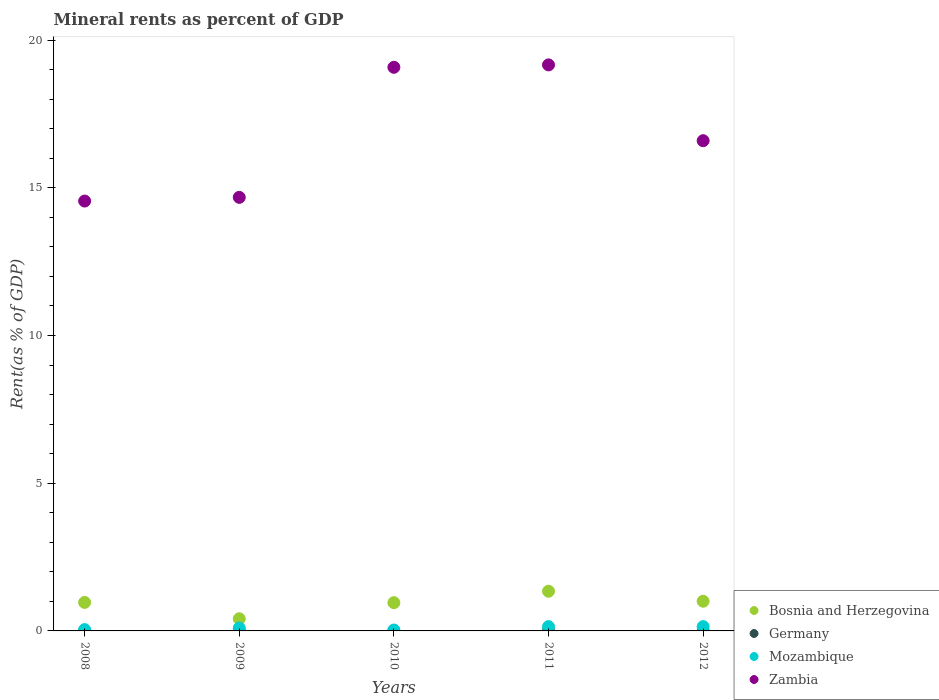How many different coloured dotlines are there?
Give a very brief answer. 4. What is the mineral rent in Germany in 2009?
Ensure brevity in your answer.  0. Across all years, what is the maximum mineral rent in Bosnia and Herzegovina?
Keep it short and to the point. 1.34. Across all years, what is the minimum mineral rent in Germany?
Offer a terse response. 0. What is the total mineral rent in Germany in the graph?
Offer a very short reply. 0.01. What is the difference between the mineral rent in Germany in 2008 and that in 2010?
Your answer should be compact. 0. What is the difference between the mineral rent in Bosnia and Herzegovina in 2008 and the mineral rent in Mozambique in 2010?
Give a very brief answer. 0.93. What is the average mineral rent in Zambia per year?
Ensure brevity in your answer.  16.81. In the year 2009, what is the difference between the mineral rent in Germany and mineral rent in Zambia?
Offer a very short reply. -14.68. In how many years, is the mineral rent in Mozambique greater than 14 %?
Your answer should be compact. 0. What is the ratio of the mineral rent in Bosnia and Herzegovina in 2010 to that in 2011?
Make the answer very short. 0.71. Is the mineral rent in Germany in 2008 less than that in 2012?
Keep it short and to the point. No. What is the difference between the highest and the second highest mineral rent in Bosnia and Herzegovina?
Offer a very short reply. 0.34. What is the difference between the highest and the lowest mineral rent in Zambia?
Offer a terse response. 4.61. Is it the case that in every year, the sum of the mineral rent in Mozambique and mineral rent in Zambia  is greater than the sum of mineral rent in Germany and mineral rent in Bosnia and Herzegovina?
Your response must be concise. No. How many dotlines are there?
Offer a terse response. 4. Are the values on the major ticks of Y-axis written in scientific E-notation?
Provide a short and direct response. No. Does the graph contain any zero values?
Offer a terse response. No. Does the graph contain grids?
Ensure brevity in your answer.  No. What is the title of the graph?
Your answer should be compact. Mineral rents as percent of GDP. What is the label or title of the Y-axis?
Offer a terse response. Rent(as % of GDP). What is the Rent(as % of GDP) of Bosnia and Herzegovina in 2008?
Your answer should be compact. 0.96. What is the Rent(as % of GDP) in Germany in 2008?
Make the answer very short. 0. What is the Rent(as % of GDP) in Mozambique in 2008?
Offer a terse response. 0.05. What is the Rent(as % of GDP) of Zambia in 2008?
Provide a short and direct response. 14.55. What is the Rent(as % of GDP) in Bosnia and Herzegovina in 2009?
Make the answer very short. 0.41. What is the Rent(as % of GDP) in Germany in 2009?
Your answer should be very brief. 0. What is the Rent(as % of GDP) of Mozambique in 2009?
Offer a very short reply. 0.1. What is the Rent(as % of GDP) of Zambia in 2009?
Provide a short and direct response. 14.68. What is the Rent(as % of GDP) of Bosnia and Herzegovina in 2010?
Make the answer very short. 0.96. What is the Rent(as % of GDP) of Germany in 2010?
Offer a terse response. 0. What is the Rent(as % of GDP) in Mozambique in 2010?
Your response must be concise. 0.03. What is the Rent(as % of GDP) of Zambia in 2010?
Make the answer very short. 19.08. What is the Rent(as % of GDP) of Bosnia and Herzegovina in 2011?
Provide a short and direct response. 1.34. What is the Rent(as % of GDP) of Germany in 2011?
Ensure brevity in your answer.  0. What is the Rent(as % of GDP) of Mozambique in 2011?
Provide a short and direct response. 0.15. What is the Rent(as % of GDP) of Zambia in 2011?
Your answer should be very brief. 19.16. What is the Rent(as % of GDP) in Bosnia and Herzegovina in 2012?
Your response must be concise. 1.01. What is the Rent(as % of GDP) in Germany in 2012?
Provide a short and direct response. 0. What is the Rent(as % of GDP) in Mozambique in 2012?
Offer a terse response. 0.15. What is the Rent(as % of GDP) of Zambia in 2012?
Provide a short and direct response. 16.6. Across all years, what is the maximum Rent(as % of GDP) of Bosnia and Herzegovina?
Offer a very short reply. 1.34. Across all years, what is the maximum Rent(as % of GDP) in Germany?
Make the answer very short. 0. Across all years, what is the maximum Rent(as % of GDP) of Mozambique?
Ensure brevity in your answer.  0.15. Across all years, what is the maximum Rent(as % of GDP) in Zambia?
Your answer should be very brief. 19.16. Across all years, what is the minimum Rent(as % of GDP) of Bosnia and Herzegovina?
Provide a short and direct response. 0.41. Across all years, what is the minimum Rent(as % of GDP) in Germany?
Give a very brief answer. 0. Across all years, what is the minimum Rent(as % of GDP) in Mozambique?
Your answer should be very brief. 0.03. Across all years, what is the minimum Rent(as % of GDP) in Zambia?
Offer a very short reply. 14.55. What is the total Rent(as % of GDP) of Bosnia and Herzegovina in the graph?
Your response must be concise. 4.68. What is the total Rent(as % of GDP) of Germany in the graph?
Provide a short and direct response. 0.01. What is the total Rent(as % of GDP) in Mozambique in the graph?
Keep it short and to the point. 0.47. What is the total Rent(as % of GDP) of Zambia in the graph?
Offer a terse response. 84.07. What is the difference between the Rent(as % of GDP) in Bosnia and Herzegovina in 2008 and that in 2009?
Your answer should be very brief. 0.55. What is the difference between the Rent(as % of GDP) in Germany in 2008 and that in 2009?
Ensure brevity in your answer.  0. What is the difference between the Rent(as % of GDP) of Mozambique in 2008 and that in 2009?
Offer a terse response. -0.05. What is the difference between the Rent(as % of GDP) in Zambia in 2008 and that in 2009?
Offer a terse response. -0.13. What is the difference between the Rent(as % of GDP) in Bosnia and Herzegovina in 2008 and that in 2010?
Make the answer very short. 0.01. What is the difference between the Rent(as % of GDP) in Germany in 2008 and that in 2010?
Your response must be concise. 0. What is the difference between the Rent(as % of GDP) in Mozambique in 2008 and that in 2010?
Offer a terse response. 0.01. What is the difference between the Rent(as % of GDP) of Zambia in 2008 and that in 2010?
Provide a succinct answer. -4.53. What is the difference between the Rent(as % of GDP) of Bosnia and Herzegovina in 2008 and that in 2011?
Provide a succinct answer. -0.38. What is the difference between the Rent(as % of GDP) in Germany in 2008 and that in 2011?
Your answer should be compact. -0. What is the difference between the Rent(as % of GDP) in Mozambique in 2008 and that in 2011?
Make the answer very short. -0.1. What is the difference between the Rent(as % of GDP) in Zambia in 2008 and that in 2011?
Give a very brief answer. -4.61. What is the difference between the Rent(as % of GDP) of Bosnia and Herzegovina in 2008 and that in 2012?
Your response must be concise. -0.04. What is the difference between the Rent(as % of GDP) in Mozambique in 2008 and that in 2012?
Offer a very short reply. -0.1. What is the difference between the Rent(as % of GDP) in Zambia in 2008 and that in 2012?
Keep it short and to the point. -2.04. What is the difference between the Rent(as % of GDP) of Bosnia and Herzegovina in 2009 and that in 2010?
Offer a very short reply. -0.54. What is the difference between the Rent(as % of GDP) of Germany in 2009 and that in 2010?
Offer a very short reply. -0. What is the difference between the Rent(as % of GDP) of Mozambique in 2009 and that in 2010?
Provide a short and direct response. 0.07. What is the difference between the Rent(as % of GDP) of Zambia in 2009 and that in 2010?
Your answer should be compact. -4.4. What is the difference between the Rent(as % of GDP) in Bosnia and Herzegovina in 2009 and that in 2011?
Your answer should be very brief. -0.93. What is the difference between the Rent(as % of GDP) of Germany in 2009 and that in 2011?
Your answer should be compact. -0. What is the difference between the Rent(as % of GDP) in Mozambique in 2009 and that in 2011?
Offer a very short reply. -0.05. What is the difference between the Rent(as % of GDP) of Zambia in 2009 and that in 2011?
Provide a succinct answer. -4.48. What is the difference between the Rent(as % of GDP) of Bosnia and Herzegovina in 2009 and that in 2012?
Offer a very short reply. -0.59. What is the difference between the Rent(as % of GDP) in Germany in 2009 and that in 2012?
Your answer should be very brief. -0. What is the difference between the Rent(as % of GDP) of Mozambique in 2009 and that in 2012?
Your response must be concise. -0.05. What is the difference between the Rent(as % of GDP) in Zambia in 2009 and that in 2012?
Offer a terse response. -1.92. What is the difference between the Rent(as % of GDP) of Bosnia and Herzegovina in 2010 and that in 2011?
Keep it short and to the point. -0.39. What is the difference between the Rent(as % of GDP) in Germany in 2010 and that in 2011?
Offer a terse response. -0. What is the difference between the Rent(as % of GDP) in Mozambique in 2010 and that in 2011?
Give a very brief answer. -0.12. What is the difference between the Rent(as % of GDP) of Zambia in 2010 and that in 2011?
Your answer should be very brief. -0.08. What is the difference between the Rent(as % of GDP) in Bosnia and Herzegovina in 2010 and that in 2012?
Your response must be concise. -0.05. What is the difference between the Rent(as % of GDP) in Mozambique in 2010 and that in 2012?
Your answer should be very brief. -0.12. What is the difference between the Rent(as % of GDP) of Zambia in 2010 and that in 2012?
Your answer should be very brief. 2.48. What is the difference between the Rent(as % of GDP) in Bosnia and Herzegovina in 2011 and that in 2012?
Your answer should be very brief. 0.34. What is the difference between the Rent(as % of GDP) of Germany in 2011 and that in 2012?
Make the answer very short. 0. What is the difference between the Rent(as % of GDP) in Mozambique in 2011 and that in 2012?
Provide a succinct answer. 0. What is the difference between the Rent(as % of GDP) in Zambia in 2011 and that in 2012?
Ensure brevity in your answer.  2.57. What is the difference between the Rent(as % of GDP) in Bosnia and Herzegovina in 2008 and the Rent(as % of GDP) in Mozambique in 2009?
Your answer should be compact. 0.87. What is the difference between the Rent(as % of GDP) of Bosnia and Herzegovina in 2008 and the Rent(as % of GDP) of Zambia in 2009?
Make the answer very short. -13.71. What is the difference between the Rent(as % of GDP) in Germany in 2008 and the Rent(as % of GDP) in Mozambique in 2009?
Your answer should be very brief. -0.1. What is the difference between the Rent(as % of GDP) in Germany in 2008 and the Rent(as % of GDP) in Zambia in 2009?
Your response must be concise. -14.68. What is the difference between the Rent(as % of GDP) of Mozambique in 2008 and the Rent(as % of GDP) of Zambia in 2009?
Your answer should be very brief. -14.63. What is the difference between the Rent(as % of GDP) of Bosnia and Herzegovina in 2008 and the Rent(as % of GDP) of Germany in 2010?
Provide a succinct answer. 0.96. What is the difference between the Rent(as % of GDP) of Bosnia and Herzegovina in 2008 and the Rent(as % of GDP) of Mozambique in 2010?
Offer a very short reply. 0.93. What is the difference between the Rent(as % of GDP) of Bosnia and Herzegovina in 2008 and the Rent(as % of GDP) of Zambia in 2010?
Provide a short and direct response. -18.12. What is the difference between the Rent(as % of GDP) of Germany in 2008 and the Rent(as % of GDP) of Mozambique in 2010?
Your response must be concise. -0.03. What is the difference between the Rent(as % of GDP) in Germany in 2008 and the Rent(as % of GDP) in Zambia in 2010?
Your answer should be compact. -19.08. What is the difference between the Rent(as % of GDP) of Mozambique in 2008 and the Rent(as % of GDP) of Zambia in 2010?
Ensure brevity in your answer.  -19.04. What is the difference between the Rent(as % of GDP) of Bosnia and Herzegovina in 2008 and the Rent(as % of GDP) of Germany in 2011?
Offer a very short reply. 0.96. What is the difference between the Rent(as % of GDP) in Bosnia and Herzegovina in 2008 and the Rent(as % of GDP) in Mozambique in 2011?
Your answer should be very brief. 0.82. What is the difference between the Rent(as % of GDP) in Bosnia and Herzegovina in 2008 and the Rent(as % of GDP) in Zambia in 2011?
Offer a terse response. -18.2. What is the difference between the Rent(as % of GDP) of Germany in 2008 and the Rent(as % of GDP) of Mozambique in 2011?
Your response must be concise. -0.14. What is the difference between the Rent(as % of GDP) of Germany in 2008 and the Rent(as % of GDP) of Zambia in 2011?
Offer a terse response. -19.16. What is the difference between the Rent(as % of GDP) of Mozambique in 2008 and the Rent(as % of GDP) of Zambia in 2011?
Give a very brief answer. -19.12. What is the difference between the Rent(as % of GDP) in Bosnia and Herzegovina in 2008 and the Rent(as % of GDP) in Germany in 2012?
Ensure brevity in your answer.  0.96. What is the difference between the Rent(as % of GDP) in Bosnia and Herzegovina in 2008 and the Rent(as % of GDP) in Mozambique in 2012?
Give a very brief answer. 0.82. What is the difference between the Rent(as % of GDP) of Bosnia and Herzegovina in 2008 and the Rent(as % of GDP) of Zambia in 2012?
Your response must be concise. -15.63. What is the difference between the Rent(as % of GDP) of Germany in 2008 and the Rent(as % of GDP) of Mozambique in 2012?
Make the answer very short. -0.14. What is the difference between the Rent(as % of GDP) of Germany in 2008 and the Rent(as % of GDP) of Zambia in 2012?
Offer a terse response. -16.59. What is the difference between the Rent(as % of GDP) in Mozambique in 2008 and the Rent(as % of GDP) in Zambia in 2012?
Your response must be concise. -16.55. What is the difference between the Rent(as % of GDP) in Bosnia and Herzegovina in 2009 and the Rent(as % of GDP) in Germany in 2010?
Give a very brief answer. 0.41. What is the difference between the Rent(as % of GDP) in Bosnia and Herzegovina in 2009 and the Rent(as % of GDP) in Mozambique in 2010?
Your answer should be very brief. 0.38. What is the difference between the Rent(as % of GDP) of Bosnia and Herzegovina in 2009 and the Rent(as % of GDP) of Zambia in 2010?
Your answer should be very brief. -18.67. What is the difference between the Rent(as % of GDP) of Germany in 2009 and the Rent(as % of GDP) of Mozambique in 2010?
Your answer should be very brief. -0.03. What is the difference between the Rent(as % of GDP) in Germany in 2009 and the Rent(as % of GDP) in Zambia in 2010?
Your response must be concise. -19.08. What is the difference between the Rent(as % of GDP) in Mozambique in 2009 and the Rent(as % of GDP) in Zambia in 2010?
Ensure brevity in your answer.  -18.98. What is the difference between the Rent(as % of GDP) in Bosnia and Herzegovina in 2009 and the Rent(as % of GDP) in Germany in 2011?
Your response must be concise. 0.41. What is the difference between the Rent(as % of GDP) of Bosnia and Herzegovina in 2009 and the Rent(as % of GDP) of Mozambique in 2011?
Give a very brief answer. 0.27. What is the difference between the Rent(as % of GDP) of Bosnia and Herzegovina in 2009 and the Rent(as % of GDP) of Zambia in 2011?
Your answer should be very brief. -18.75. What is the difference between the Rent(as % of GDP) in Germany in 2009 and the Rent(as % of GDP) in Mozambique in 2011?
Ensure brevity in your answer.  -0.15. What is the difference between the Rent(as % of GDP) in Germany in 2009 and the Rent(as % of GDP) in Zambia in 2011?
Keep it short and to the point. -19.16. What is the difference between the Rent(as % of GDP) in Mozambique in 2009 and the Rent(as % of GDP) in Zambia in 2011?
Provide a succinct answer. -19.06. What is the difference between the Rent(as % of GDP) in Bosnia and Herzegovina in 2009 and the Rent(as % of GDP) in Germany in 2012?
Offer a very short reply. 0.41. What is the difference between the Rent(as % of GDP) of Bosnia and Herzegovina in 2009 and the Rent(as % of GDP) of Mozambique in 2012?
Your answer should be very brief. 0.27. What is the difference between the Rent(as % of GDP) of Bosnia and Herzegovina in 2009 and the Rent(as % of GDP) of Zambia in 2012?
Make the answer very short. -16.18. What is the difference between the Rent(as % of GDP) in Germany in 2009 and the Rent(as % of GDP) in Mozambique in 2012?
Provide a succinct answer. -0.15. What is the difference between the Rent(as % of GDP) in Germany in 2009 and the Rent(as % of GDP) in Zambia in 2012?
Your answer should be very brief. -16.6. What is the difference between the Rent(as % of GDP) in Mozambique in 2009 and the Rent(as % of GDP) in Zambia in 2012?
Ensure brevity in your answer.  -16.5. What is the difference between the Rent(as % of GDP) in Bosnia and Herzegovina in 2010 and the Rent(as % of GDP) in Germany in 2011?
Keep it short and to the point. 0.95. What is the difference between the Rent(as % of GDP) of Bosnia and Herzegovina in 2010 and the Rent(as % of GDP) of Mozambique in 2011?
Make the answer very short. 0.81. What is the difference between the Rent(as % of GDP) in Bosnia and Herzegovina in 2010 and the Rent(as % of GDP) in Zambia in 2011?
Keep it short and to the point. -18.21. What is the difference between the Rent(as % of GDP) in Germany in 2010 and the Rent(as % of GDP) in Mozambique in 2011?
Offer a terse response. -0.14. What is the difference between the Rent(as % of GDP) in Germany in 2010 and the Rent(as % of GDP) in Zambia in 2011?
Your answer should be compact. -19.16. What is the difference between the Rent(as % of GDP) of Mozambique in 2010 and the Rent(as % of GDP) of Zambia in 2011?
Make the answer very short. -19.13. What is the difference between the Rent(as % of GDP) in Bosnia and Herzegovina in 2010 and the Rent(as % of GDP) in Germany in 2012?
Ensure brevity in your answer.  0.96. What is the difference between the Rent(as % of GDP) of Bosnia and Herzegovina in 2010 and the Rent(as % of GDP) of Mozambique in 2012?
Provide a short and direct response. 0.81. What is the difference between the Rent(as % of GDP) of Bosnia and Herzegovina in 2010 and the Rent(as % of GDP) of Zambia in 2012?
Keep it short and to the point. -15.64. What is the difference between the Rent(as % of GDP) in Germany in 2010 and the Rent(as % of GDP) in Mozambique in 2012?
Your response must be concise. -0.14. What is the difference between the Rent(as % of GDP) of Germany in 2010 and the Rent(as % of GDP) of Zambia in 2012?
Offer a very short reply. -16.6. What is the difference between the Rent(as % of GDP) in Mozambique in 2010 and the Rent(as % of GDP) in Zambia in 2012?
Your answer should be very brief. -16.57. What is the difference between the Rent(as % of GDP) of Bosnia and Herzegovina in 2011 and the Rent(as % of GDP) of Germany in 2012?
Keep it short and to the point. 1.34. What is the difference between the Rent(as % of GDP) of Bosnia and Herzegovina in 2011 and the Rent(as % of GDP) of Mozambique in 2012?
Provide a succinct answer. 1.2. What is the difference between the Rent(as % of GDP) in Bosnia and Herzegovina in 2011 and the Rent(as % of GDP) in Zambia in 2012?
Provide a short and direct response. -15.25. What is the difference between the Rent(as % of GDP) in Germany in 2011 and the Rent(as % of GDP) in Mozambique in 2012?
Your answer should be very brief. -0.14. What is the difference between the Rent(as % of GDP) in Germany in 2011 and the Rent(as % of GDP) in Zambia in 2012?
Ensure brevity in your answer.  -16.59. What is the difference between the Rent(as % of GDP) of Mozambique in 2011 and the Rent(as % of GDP) of Zambia in 2012?
Your answer should be compact. -16.45. What is the average Rent(as % of GDP) of Bosnia and Herzegovina per year?
Keep it short and to the point. 0.94. What is the average Rent(as % of GDP) in Germany per year?
Provide a succinct answer. 0. What is the average Rent(as % of GDP) in Mozambique per year?
Provide a succinct answer. 0.09. What is the average Rent(as % of GDP) of Zambia per year?
Provide a short and direct response. 16.81. In the year 2008, what is the difference between the Rent(as % of GDP) of Bosnia and Herzegovina and Rent(as % of GDP) of Germany?
Keep it short and to the point. 0.96. In the year 2008, what is the difference between the Rent(as % of GDP) of Bosnia and Herzegovina and Rent(as % of GDP) of Mozambique?
Your response must be concise. 0.92. In the year 2008, what is the difference between the Rent(as % of GDP) of Bosnia and Herzegovina and Rent(as % of GDP) of Zambia?
Offer a very short reply. -13.59. In the year 2008, what is the difference between the Rent(as % of GDP) of Germany and Rent(as % of GDP) of Mozambique?
Make the answer very short. -0.04. In the year 2008, what is the difference between the Rent(as % of GDP) of Germany and Rent(as % of GDP) of Zambia?
Keep it short and to the point. -14.55. In the year 2008, what is the difference between the Rent(as % of GDP) in Mozambique and Rent(as % of GDP) in Zambia?
Keep it short and to the point. -14.51. In the year 2009, what is the difference between the Rent(as % of GDP) in Bosnia and Herzegovina and Rent(as % of GDP) in Germany?
Offer a terse response. 0.41. In the year 2009, what is the difference between the Rent(as % of GDP) in Bosnia and Herzegovina and Rent(as % of GDP) in Mozambique?
Make the answer very short. 0.31. In the year 2009, what is the difference between the Rent(as % of GDP) of Bosnia and Herzegovina and Rent(as % of GDP) of Zambia?
Give a very brief answer. -14.27. In the year 2009, what is the difference between the Rent(as % of GDP) of Germany and Rent(as % of GDP) of Mozambique?
Offer a terse response. -0.1. In the year 2009, what is the difference between the Rent(as % of GDP) of Germany and Rent(as % of GDP) of Zambia?
Your answer should be compact. -14.68. In the year 2009, what is the difference between the Rent(as % of GDP) in Mozambique and Rent(as % of GDP) in Zambia?
Offer a terse response. -14.58. In the year 2010, what is the difference between the Rent(as % of GDP) in Bosnia and Herzegovina and Rent(as % of GDP) in Germany?
Give a very brief answer. 0.96. In the year 2010, what is the difference between the Rent(as % of GDP) in Bosnia and Herzegovina and Rent(as % of GDP) in Mozambique?
Make the answer very short. 0.93. In the year 2010, what is the difference between the Rent(as % of GDP) in Bosnia and Herzegovina and Rent(as % of GDP) in Zambia?
Provide a short and direct response. -18.12. In the year 2010, what is the difference between the Rent(as % of GDP) of Germany and Rent(as % of GDP) of Mozambique?
Your answer should be compact. -0.03. In the year 2010, what is the difference between the Rent(as % of GDP) in Germany and Rent(as % of GDP) in Zambia?
Keep it short and to the point. -19.08. In the year 2010, what is the difference between the Rent(as % of GDP) in Mozambique and Rent(as % of GDP) in Zambia?
Provide a succinct answer. -19.05. In the year 2011, what is the difference between the Rent(as % of GDP) of Bosnia and Herzegovina and Rent(as % of GDP) of Germany?
Your response must be concise. 1.34. In the year 2011, what is the difference between the Rent(as % of GDP) of Bosnia and Herzegovina and Rent(as % of GDP) of Mozambique?
Your answer should be compact. 1.2. In the year 2011, what is the difference between the Rent(as % of GDP) in Bosnia and Herzegovina and Rent(as % of GDP) in Zambia?
Ensure brevity in your answer.  -17.82. In the year 2011, what is the difference between the Rent(as % of GDP) of Germany and Rent(as % of GDP) of Mozambique?
Make the answer very short. -0.14. In the year 2011, what is the difference between the Rent(as % of GDP) in Germany and Rent(as % of GDP) in Zambia?
Offer a terse response. -19.16. In the year 2011, what is the difference between the Rent(as % of GDP) of Mozambique and Rent(as % of GDP) of Zambia?
Provide a succinct answer. -19.02. In the year 2012, what is the difference between the Rent(as % of GDP) of Bosnia and Herzegovina and Rent(as % of GDP) of Germany?
Provide a succinct answer. 1. In the year 2012, what is the difference between the Rent(as % of GDP) in Bosnia and Herzegovina and Rent(as % of GDP) in Mozambique?
Give a very brief answer. 0.86. In the year 2012, what is the difference between the Rent(as % of GDP) in Bosnia and Herzegovina and Rent(as % of GDP) in Zambia?
Provide a succinct answer. -15.59. In the year 2012, what is the difference between the Rent(as % of GDP) of Germany and Rent(as % of GDP) of Mozambique?
Provide a short and direct response. -0.14. In the year 2012, what is the difference between the Rent(as % of GDP) in Germany and Rent(as % of GDP) in Zambia?
Your response must be concise. -16.6. In the year 2012, what is the difference between the Rent(as % of GDP) of Mozambique and Rent(as % of GDP) of Zambia?
Your answer should be very brief. -16.45. What is the ratio of the Rent(as % of GDP) in Bosnia and Herzegovina in 2008 to that in 2009?
Offer a terse response. 2.34. What is the ratio of the Rent(as % of GDP) in Germany in 2008 to that in 2009?
Offer a terse response. 3.35. What is the ratio of the Rent(as % of GDP) of Mozambique in 2008 to that in 2009?
Keep it short and to the point. 0.46. What is the ratio of the Rent(as % of GDP) of Bosnia and Herzegovina in 2008 to that in 2010?
Ensure brevity in your answer.  1.01. What is the ratio of the Rent(as % of GDP) in Germany in 2008 to that in 2010?
Your answer should be very brief. 1.15. What is the ratio of the Rent(as % of GDP) in Mozambique in 2008 to that in 2010?
Provide a short and direct response. 1.48. What is the ratio of the Rent(as % of GDP) in Zambia in 2008 to that in 2010?
Your answer should be very brief. 0.76. What is the ratio of the Rent(as % of GDP) of Bosnia and Herzegovina in 2008 to that in 2011?
Offer a very short reply. 0.72. What is the ratio of the Rent(as % of GDP) in Germany in 2008 to that in 2011?
Keep it short and to the point. 0.86. What is the ratio of the Rent(as % of GDP) in Mozambique in 2008 to that in 2011?
Ensure brevity in your answer.  0.31. What is the ratio of the Rent(as % of GDP) in Zambia in 2008 to that in 2011?
Your response must be concise. 0.76. What is the ratio of the Rent(as % of GDP) of Bosnia and Herzegovina in 2008 to that in 2012?
Your answer should be very brief. 0.96. What is the ratio of the Rent(as % of GDP) in Germany in 2008 to that in 2012?
Keep it short and to the point. 1.3. What is the ratio of the Rent(as % of GDP) of Mozambique in 2008 to that in 2012?
Your answer should be compact. 0.31. What is the ratio of the Rent(as % of GDP) of Zambia in 2008 to that in 2012?
Offer a terse response. 0.88. What is the ratio of the Rent(as % of GDP) in Bosnia and Herzegovina in 2009 to that in 2010?
Make the answer very short. 0.43. What is the ratio of the Rent(as % of GDP) of Germany in 2009 to that in 2010?
Offer a very short reply. 0.34. What is the ratio of the Rent(as % of GDP) of Mozambique in 2009 to that in 2010?
Your answer should be compact. 3.23. What is the ratio of the Rent(as % of GDP) of Zambia in 2009 to that in 2010?
Your response must be concise. 0.77. What is the ratio of the Rent(as % of GDP) of Bosnia and Herzegovina in 2009 to that in 2011?
Provide a succinct answer. 0.31. What is the ratio of the Rent(as % of GDP) of Germany in 2009 to that in 2011?
Your response must be concise. 0.26. What is the ratio of the Rent(as % of GDP) in Mozambique in 2009 to that in 2011?
Ensure brevity in your answer.  0.67. What is the ratio of the Rent(as % of GDP) of Zambia in 2009 to that in 2011?
Provide a short and direct response. 0.77. What is the ratio of the Rent(as % of GDP) of Bosnia and Herzegovina in 2009 to that in 2012?
Ensure brevity in your answer.  0.41. What is the ratio of the Rent(as % of GDP) in Germany in 2009 to that in 2012?
Your response must be concise. 0.39. What is the ratio of the Rent(as % of GDP) of Mozambique in 2009 to that in 2012?
Offer a terse response. 0.67. What is the ratio of the Rent(as % of GDP) in Zambia in 2009 to that in 2012?
Your answer should be compact. 0.88. What is the ratio of the Rent(as % of GDP) of Bosnia and Herzegovina in 2010 to that in 2011?
Give a very brief answer. 0.71. What is the ratio of the Rent(as % of GDP) of Germany in 2010 to that in 2011?
Ensure brevity in your answer.  0.75. What is the ratio of the Rent(as % of GDP) in Mozambique in 2010 to that in 2011?
Give a very brief answer. 0.21. What is the ratio of the Rent(as % of GDP) in Zambia in 2010 to that in 2011?
Provide a succinct answer. 1. What is the ratio of the Rent(as % of GDP) of Bosnia and Herzegovina in 2010 to that in 2012?
Your answer should be compact. 0.95. What is the ratio of the Rent(as % of GDP) of Germany in 2010 to that in 2012?
Your answer should be very brief. 1.13. What is the ratio of the Rent(as % of GDP) of Mozambique in 2010 to that in 2012?
Give a very brief answer. 0.21. What is the ratio of the Rent(as % of GDP) of Zambia in 2010 to that in 2012?
Ensure brevity in your answer.  1.15. What is the ratio of the Rent(as % of GDP) of Bosnia and Herzegovina in 2011 to that in 2012?
Your answer should be very brief. 1.34. What is the ratio of the Rent(as % of GDP) in Germany in 2011 to that in 2012?
Your answer should be very brief. 1.51. What is the ratio of the Rent(as % of GDP) of Mozambique in 2011 to that in 2012?
Your answer should be compact. 1. What is the ratio of the Rent(as % of GDP) of Zambia in 2011 to that in 2012?
Offer a terse response. 1.15. What is the difference between the highest and the second highest Rent(as % of GDP) in Bosnia and Herzegovina?
Offer a terse response. 0.34. What is the difference between the highest and the second highest Rent(as % of GDP) in Germany?
Offer a very short reply. 0. What is the difference between the highest and the second highest Rent(as % of GDP) of Zambia?
Your answer should be very brief. 0.08. What is the difference between the highest and the lowest Rent(as % of GDP) of Bosnia and Herzegovina?
Make the answer very short. 0.93. What is the difference between the highest and the lowest Rent(as % of GDP) of Germany?
Ensure brevity in your answer.  0. What is the difference between the highest and the lowest Rent(as % of GDP) of Mozambique?
Provide a succinct answer. 0.12. What is the difference between the highest and the lowest Rent(as % of GDP) in Zambia?
Your answer should be very brief. 4.61. 